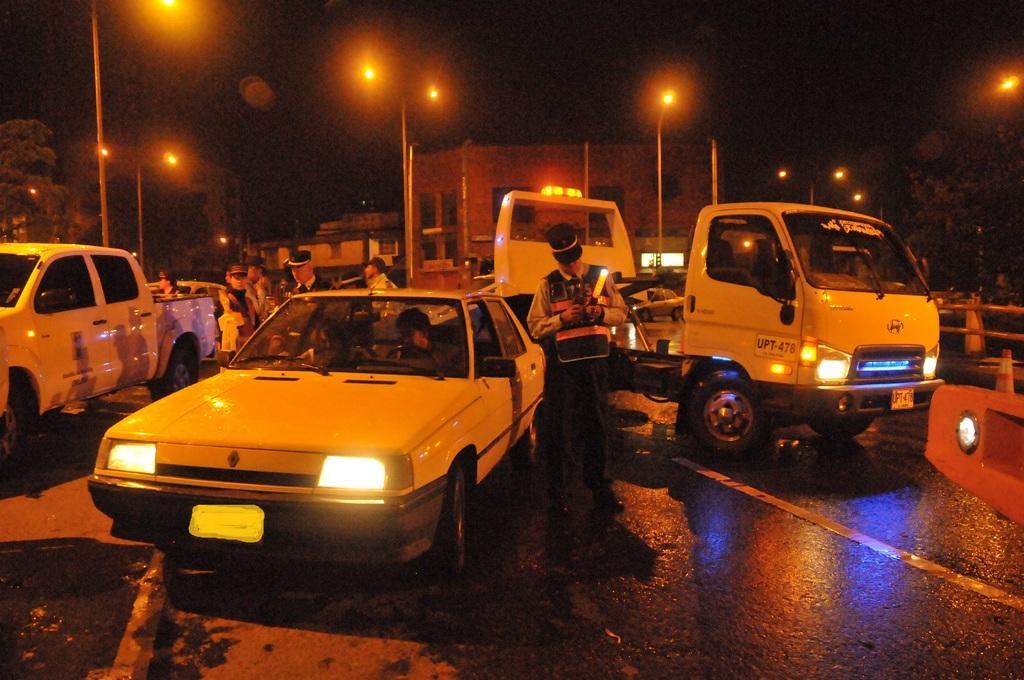In one or two sentences, can you explain what this image depicts? In this image, we can see vehicles and people on the road and in the background, there are lights, trees, buildings and we can see traffic cones. 